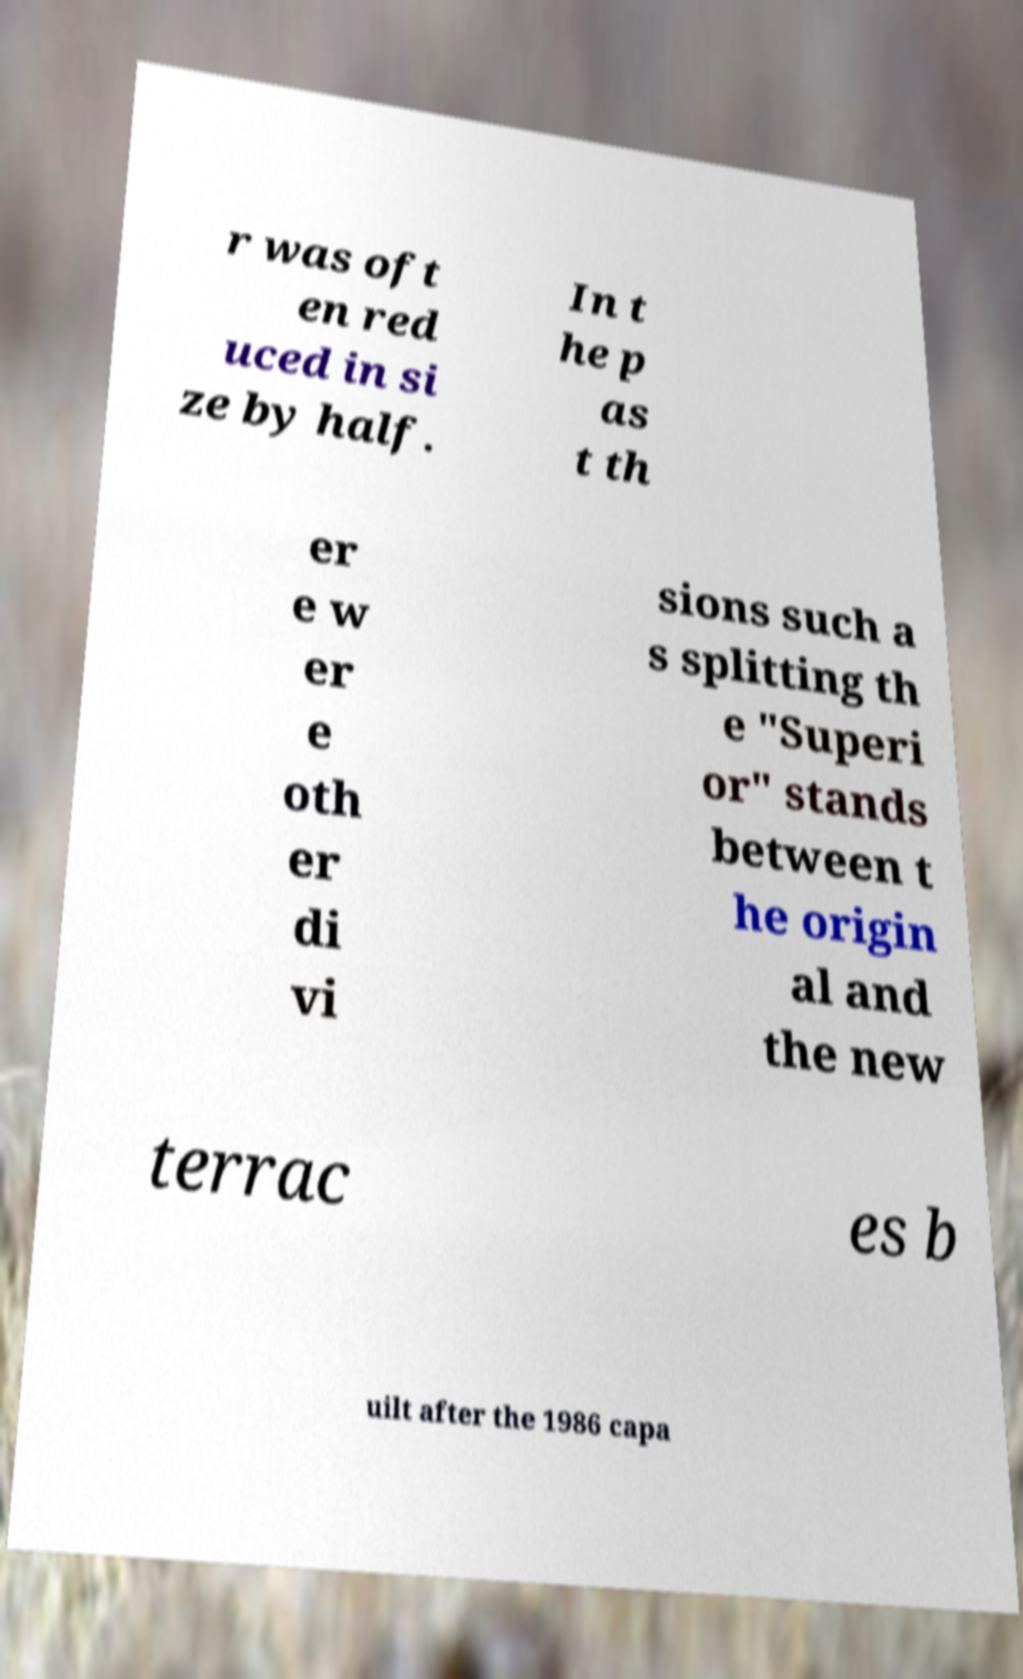What messages or text are displayed in this image? I need them in a readable, typed format. r was oft en red uced in si ze by half. In t he p as t th er e w er e oth er di vi sions such a s splitting th e "Superi or" stands between t he origin al and the new terrac es b uilt after the 1986 capa 